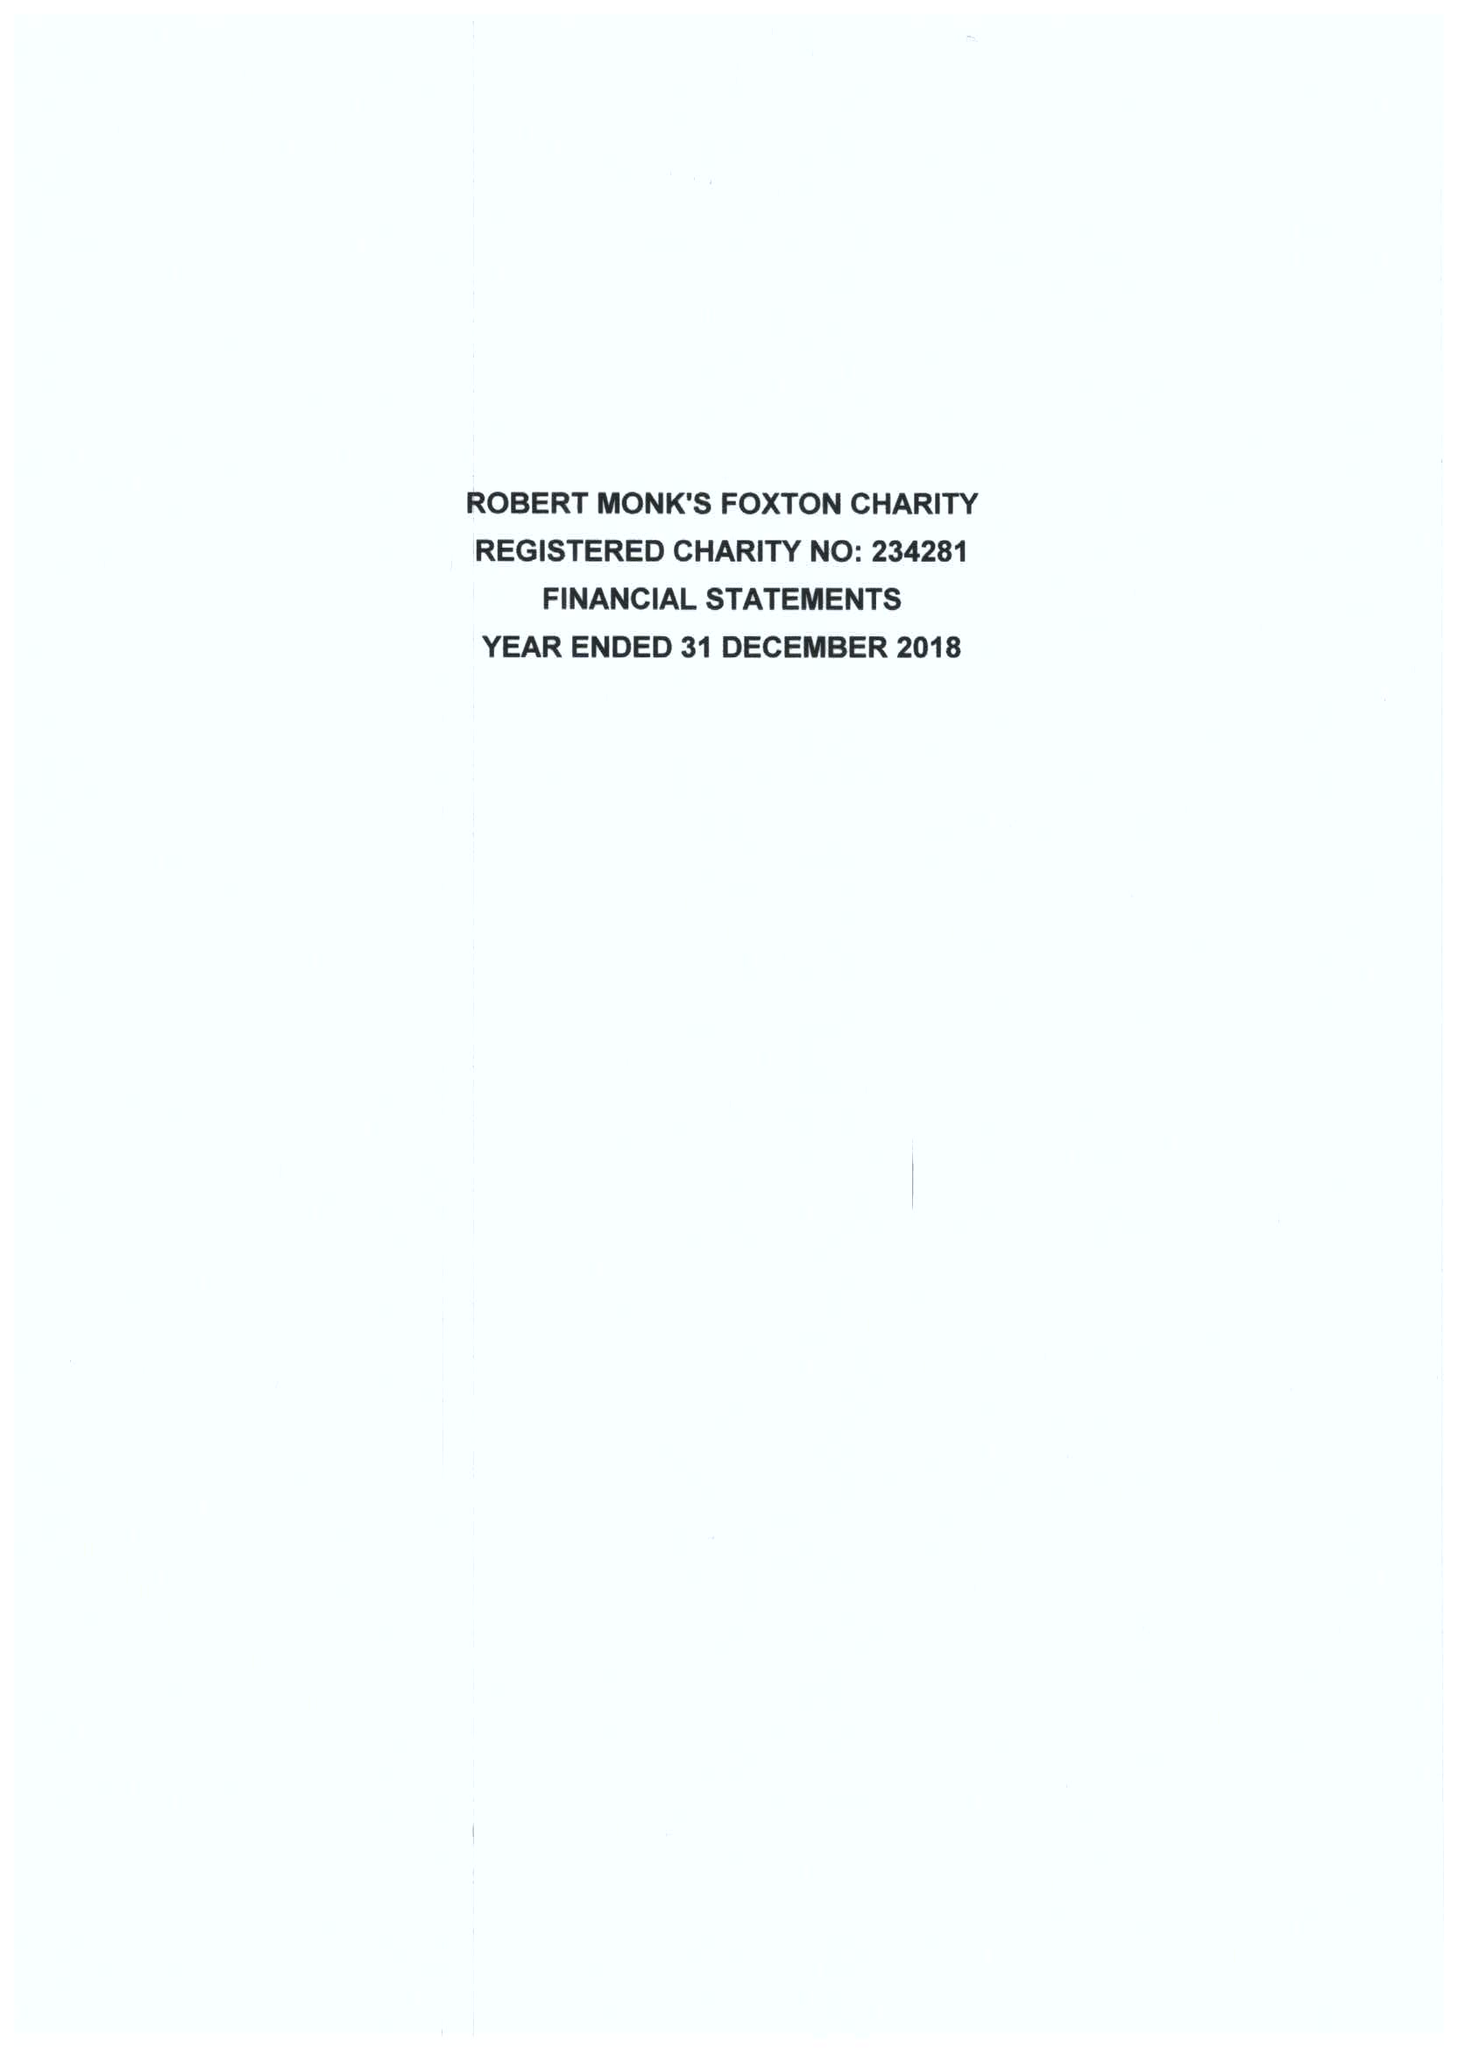What is the value for the address__postcode?
Answer the question using a single word or phrase. LE16 7RE 